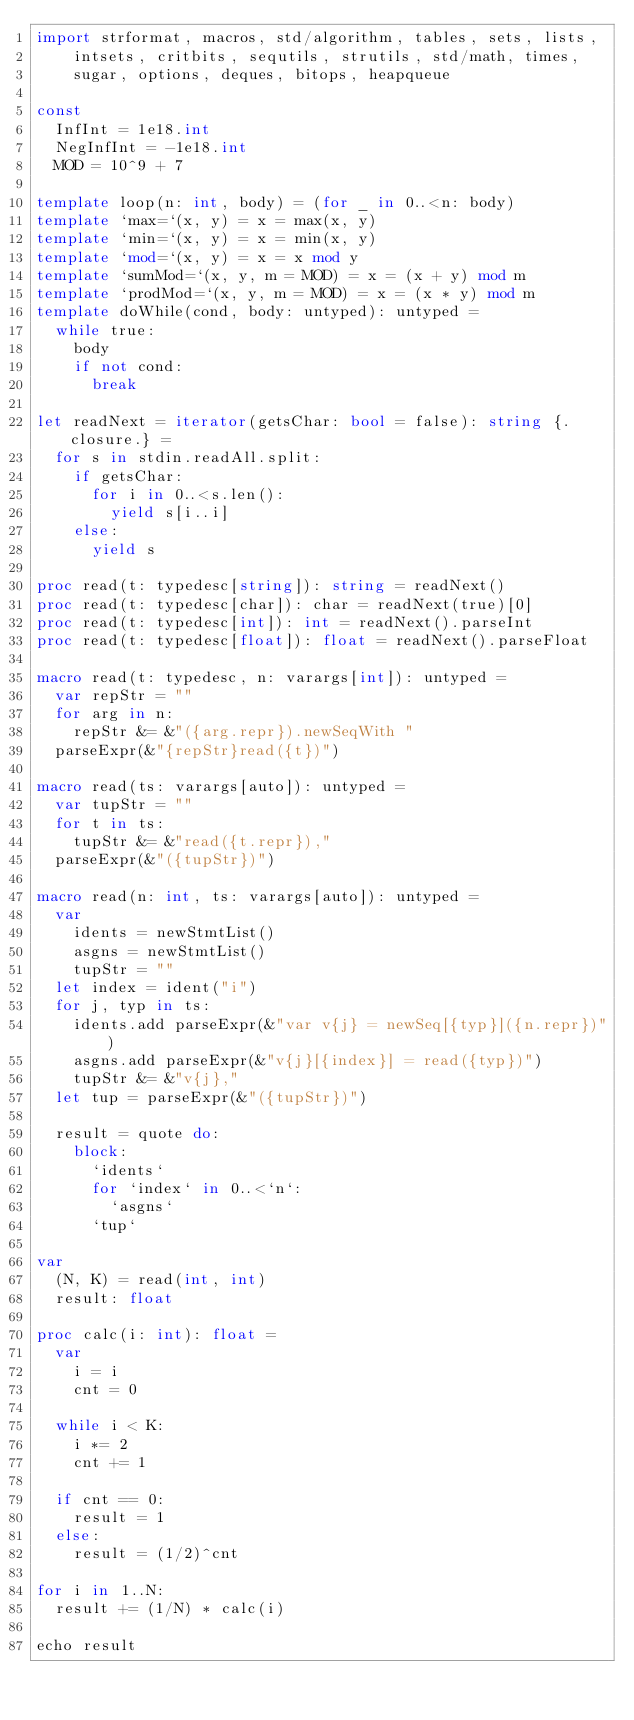Convert code to text. <code><loc_0><loc_0><loc_500><loc_500><_Nim_>import strformat, macros, std/algorithm, tables, sets, lists,
    intsets, critbits, sequtils, strutils, std/math, times,
    sugar, options, deques, bitops, heapqueue

const
  InfInt = 1e18.int
  NegInfInt = -1e18.int
  MOD = 10^9 + 7

template loop(n: int, body) = (for _ in 0..<n: body)
template `max=`(x, y) = x = max(x, y)
template `min=`(x, y) = x = min(x, y)
template `mod=`(x, y) = x = x mod y
template `sumMod=`(x, y, m = MOD) = x = (x + y) mod m
template `prodMod=`(x, y, m = MOD) = x = (x * y) mod m
template doWhile(cond, body: untyped): untyped =
  while true:
    body
    if not cond:
      break

let readNext = iterator(getsChar: bool = false): string {.closure.} =
  for s in stdin.readAll.split:
    if getsChar:
      for i in 0..<s.len():
        yield s[i..i]
    else:
      yield s

proc read(t: typedesc[string]): string = readNext()
proc read(t: typedesc[char]): char = readNext(true)[0]
proc read(t: typedesc[int]): int = readNext().parseInt
proc read(t: typedesc[float]): float = readNext().parseFloat

macro read(t: typedesc, n: varargs[int]): untyped =
  var repStr = ""
  for arg in n:
    repStr &= &"({arg.repr}).newSeqWith "
  parseExpr(&"{repStr}read({t})")

macro read(ts: varargs[auto]): untyped =
  var tupStr = ""
  for t in ts:
    tupStr &= &"read({t.repr}),"
  parseExpr(&"({tupStr})")

macro read(n: int, ts: varargs[auto]): untyped =
  var
    idents = newStmtList()
    asgns = newStmtList()
    tupStr = ""
  let index = ident("i")
  for j, typ in ts:
    idents.add parseExpr(&"var v{j} = newSeq[{typ}]({n.repr})")
    asgns.add parseExpr(&"v{j}[{index}] = read({typ})")
    tupStr &= &"v{j},"
  let tup = parseExpr(&"({tupStr})")

  result = quote do:
    block:
      `idents`
      for `index` in 0..<`n`:
        `asgns`
      `tup`

var
  (N, K) = read(int, int)
  result: float

proc calc(i: int): float =
  var
    i = i
    cnt = 0

  while i < K:
    i *= 2
    cnt += 1

  if cnt == 0:
    result = 1
  else:
    result = (1/2)^cnt

for i in 1..N:
  result += (1/N) * calc(i)

echo result
</code> 